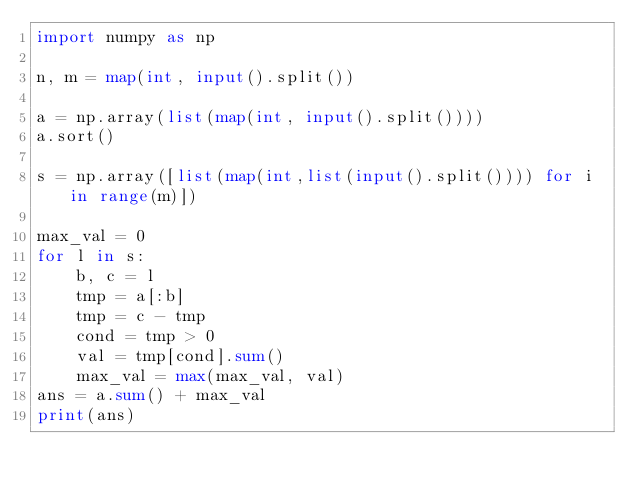Convert code to text. <code><loc_0><loc_0><loc_500><loc_500><_Python_>import numpy as np

n, m = map(int, input().split())

a = np.array(list(map(int, input().split())))
a.sort()

s = np.array([list(map(int,list(input().split()))) for i in range(m)])

max_val = 0
for l in s:
    b, c = l
    tmp = a[:b]
    tmp = c - tmp
    cond = tmp > 0
    val = tmp[cond].sum()
    max_val = max(max_val, val)
ans = a.sum() + max_val
print(ans)


</code> 